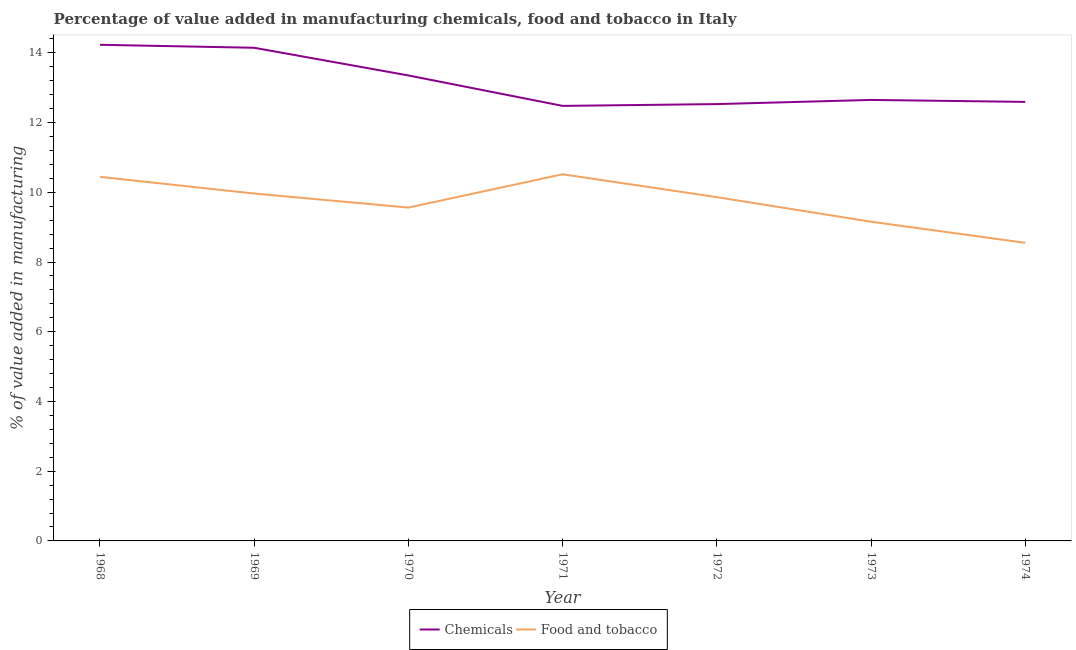How many different coloured lines are there?
Offer a terse response. 2. Does the line corresponding to value added by manufacturing food and tobacco intersect with the line corresponding to value added by  manufacturing chemicals?
Make the answer very short. No. What is the value added by  manufacturing chemicals in 1972?
Your answer should be compact. 12.53. Across all years, what is the maximum value added by  manufacturing chemicals?
Offer a very short reply. 14.23. Across all years, what is the minimum value added by  manufacturing chemicals?
Keep it short and to the point. 12.48. In which year was the value added by  manufacturing chemicals maximum?
Offer a terse response. 1968. In which year was the value added by  manufacturing chemicals minimum?
Your response must be concise. 1971. What is the total value added by manufacturing food and tobacco in the graph?
Your answer should be very brief. 68.05. What is the difference between the value added by  manufacturing chemicals in 1972 and that in 1974?
Your answer should be compact. -0.06. What is the difference between the value added by manufacturing food and tobacco in 1968 and the value added by  manufacturing chemicals in 1973?
Your answer should be compact. -2.21. What is the average value added by manufacturing food and tobacco per year?
Provide a succinct answer. 9.72. In the year 1969, what is the difference between the value added by  manufacturing chemicals and value added by manufacturing food and tobacco?
Offer a terse response. 4.18. In how many years, is the value added by  manufacturing chemicals greater than 14 %?
Give a very brief answer. 2. What is the ratio of the value added by manufacturing food and tobacco in 1971 to that in 1974?
Make the answer very short. 1.23. What is the difference between the highest and the second highest value added by  manufacturing chemicals?
Your answer should be very brief. 0.09. What is the difference between the highest and the lowest value added by  manufacturing chemicals?
Offer a very short reply. 1.75. Is the value added by  manufacturing chemicals strictly less than the value added by manufacturing food and tobacco over the years?
Make the answer very short. No. How many lines are there?
Your answer should be compact. 2. How many years are there in the graph?
Provide a succinct answer. 7. What is the difference between two consecutive major ticks on the Y-axis?
Your answer should be very brief. 2. Are the values on the major ticks of Y-axis written in scientific E-notation?
Offer a very short reply. No. Does the graph contain grids?
Provide a short and direct response. No. How many legend labels are there?
Your answer should be compact. 2. What is the title of the graph?
Ensure brevity in your answer.  Percentage of value added in manufacturing chemicals, food and tobacco in Italy. What is the label or title of the Y-axis?
Your response must be concise. % of value added in manufacturing. What is the % of value added in manufacturing in Chemicals in 1968?
Keep it short and to the point. 14.23. What is the % of value added in manufacturing of Food and tobacco in 1968?
Your answer should be very brief. 10.44. What is the % of value added in manufacturing of Chemicals in 1969?
Your response must be concise. 14.14. What is the % of value added in manufacturing in Food and tobacco in 1969?
Provide a short and direct response. 9.96. What is the % of value added in manufacturing of Chemicals in 1970?
Your answer should be compact. 13.35. What is the % of value added in manufacturing in Food and tobacco in 1970?
Offer a terse response. 9.56. What is the % of value added in manufacturing in Chemicals in 1971?
Your answer should be compact. 12.48. What is the % of value added in manufacturing in Food and tobacco in 1971?
Offer a terse response. 10.52. What is the % of value added in manufacturing in Chemicals in 1972?
Offer a terse response. 12.53. What is the % of value added in manufacturing in Food and tobacco in 1972?
Offer a very short reply. 9.86. What is the % of value added in manufacturing in Chemicals in 1973?
Keep it short and to the point. 12.65. What is the % of value added in manufacturing of Food and tobacco in 1973?
Give a very brief answer. 9.16. What is the % of value added in manufacturing in Chemicals in 1974?
Offer a terse response. 12.59. What is the % of value added in manufacturing in Food and tobacco in 1974?
Offer a terse response. 8.55. Across all years, what is the maximum % of value added in manufacturing in Chemicals?
Your answer should be compact. 14.23. Across all years, what is the maximum % of value added in manufacturing in Food and tobacco?
Ensure brevity in your answer.  10.52. Across all years, what is the minimum % of value added in manufacturing of Chemicals?
Your answer should be compact. 12.48. Across all years, what is the minimum % of value added in manufacturing in Food and tobacco?
Keep it short and to the point. 8.55. What is the total % of value added in manufacturing in Chemicals in the graph?
Make the answer very short. 91.98. What is the total % of value added in manufacturing in Food and tobacco in the graph?
Offer a very short reply. 68.05. What is the difference between the % of value added in manufacturing in Chemicals in 1968 and that in 1969?
Offer a very short reply. 0.09. What is the difference between the % of value added in manufacturing of Food and tobacco in 1968 and that in 1969?
Ensure brevity in your answer.  0.48. What is the difference between the % of value added in manufacturing of Chemicals in 1968 and that in 1970?
Give a very brief answer. 0.88. What is the difference between the % of value added in manufacturing in Food and tobacco in 1968 and that in 1970?
Provide a succinct answer. 0.88. What is the difference between the % of value added in manufacturing of Chemicals in 1968 and that in 1971?
Keep it short and to the point. 1.75. What is the difference between the % of value added in manufacturing of Food and tobacco in 1968 and that in 1971?
Offer a very short reply. -0.07. What is the difference between the % of value added in manufacturing in Chemicals in 1968 and that in 1972?
Offer a terse response. 1.7. What is the difference between the % of value added in manufacturing of Food and tobacco in 1968 and that in 1972?
Keep it short and to the point. 0.58. What is the difference between the % of value added in manufacturing of Chemicals in 1968 and that in 1973?
Ensure brevity in your answer.  1.58. What is the difference between the % of value added in manufacturing of Food and tobacco in 1968 and that in 1973?
Your answer should be very brief. 1.29. What is the difference between the % of value added in manufacturing in Chemicals in 1968 and that in 1974?
Make the answer very short. 1.64. What is the difference between the % of value added in manufacturing of Food and tobacco in 1968 and that in 1974?
Keep it short and to the point. 1.89. What is the difference between the % of value added in manufacturing in Chemicals in 1969 and that in 1970?
Your answer should be very brief. 0.79. What is the difference between the % of value added in manufacturing of Food and tobacco in 1969 and that in 1970?
Give a very brief answer. 0.4. What is the difference between the % of value added in manufacturing in Chemicals in 1969 and that in 1971?
Offer a very short reply. 1.67. What is the difference between the % of value added in manufacturing of Food and tobacco in 1969 and that in 1971?
Your response must be concise. -0.55. What is the difference between the % of value added in manufacturing of Chemicals in 1969 and that in 1972?
Provide a succinct answer. 1.62. What is the difference between the % of value added in manufacturing in Food and tobacco in 1969 and that in 1972?
Your answer should be very brief. 0.1. What is the difference between the % of value added in manufacturing in Chemicals in 1969 and that in 1973?
Your answer should be compact. 1.5. What is the difference between the % of value added in manufacturing in Food and tobacco in 1969 and that in 1973?
Your response must be concise. 0.81. What is the difference between the % of value added in manufacturing in Chemicals in 1969 and that in 1974?
Ensure brevity in your answer.  1.55. What is the difference between the % of value added in manufacturing of Food and tobacco in 1969 and that in 1974?
Offer a terse response. 1.41. What is the difference between the % of value added in manufacturing in Chemicals in 1970 and that in 1971?
Your answer should be very brief. 0.87. What is the difference between the % of value added in manufacturing of Food and tobacco in 1970 and that in 1971?
Offer a terse response. -0.95. What is the difference between the % of value added in manufacturing in Chemicals in 1970 and that in 1972?
Your answer should be very brief. 0.82. What is the difference between the % of value added in manufacturing in Food and tobacco in 1970 and that in 1972?
Provide a succinct answer. -0.3. What is the difference between the % of value added in manufacturing of Chemicals in 1970 and that in 1973?
Offer a terse response. 0.7. What is the difference between the % of value added in manufacturing in Food and tobacco in 1970 and that in 1973?
Make the answer very short. 0.41. What is the difference between the % of value added in manufacturing in Chemicals in 1970 and that in 1974?
Offer a terse response. 0.76. What is the difference between the % of value added in manufacturing of Food and tobacco in 1970 and that in 1974?
Offer a terse response. 1.01. What is the difference between the % of value added in manufacturing in Chemicals in 1971 and that in 1972?
Your response must be concise. -0.05. What is the difference between the % of value added in manufacturing of Food and tobacco in 1971 and that in 1972?
Give a very brief answer. 0.66. What is the difference between the % of value added in manufacturing of Chemicals in 1971 and that in 1973?
Your answer should be very brief. -0.17. What is the difference between the % of value added in manufacturing in Food and tobacco in 1971 and that in 1973?
Your response must be concise. 1.36. What is the difference between the % of value added in manufacturing in Chemicals in 1971 and that in 1974?
Provide a short and direct response. -0.11. What is the difference between the % of value added in manufacturing of Food and tobacco in 1971 and that in 1974?
Offer a terse response. 1.97. What is the difference between the % of value added in manufacturing of Chemicals in 1972 and that in 1973?
Ensure brevity in your answer.  -0.12. What is the difference between the % of value added in manufacturing in Food and tobacco in 1972 and that in 1973?
Your answer should be compact. 0.7. What is the difference between the % of value added in manufacturing in Chemicals in 1972 and that in 1974?
Ensure brevity in your answer.  -0.06. What is the difference between the % of value added in manufacturing in Food and tobacco in 1972 and that in 1974?
Your answer should be very brief. 1.31. What is the difference between the % of value added in manufacturing in Chemicals in 1973 and that in 1974?
Your answer should be compact. 0.06. What is the difference between the % of value added in manufacturing in Food and tobacco in 1973 and that in 1974?
Your answer should be compact. 0.61. What is the difference between the % of value added in manufacturing in Chemicals in 1968 and the % of value added in manufacturing in Food and tobacco in 1969?
Offer a terse response. 4.27. What is the difference between the % of value added in manufacturing of Chemicals in 1968 and the % of value added in manufacturing of Food and tobacco in 1970?
Offer a terse response. 4.67. What is the difference between the % of value added in manufacturing of Chemicals in 1968 and the % of value added in manufacturing of Food and tobacco in 1971?
Ensure brevity in your answer.  3.71. What is the difference between the % of value added in manufacturing of Chemicals in 1968 and the % of value added in manufacturing of Food and tobacco in 1972?
Your response must be concise. 4.37. What is the difference between the % of value added in manufacturing in Chemicals in 1968 and the % of value added in manufacturing in Food and tobacco in 1973?
Give a very brief answer. 5.08. What is the difference between the % of value added in manufacturing of Chemicals in 1968 and the % of value added in manufacturing of Food and tobacco in 1974?
Ensure brevity in your answer.  5.68. What is the difference between the % of value added in manufacturing in Chemicals in 1969 and the % of value added in manufacturing in Food and tobacco in 1970?
Provide a succinct answer. 4.58. What is the difference between the % of value added in manufacturing in Chemicals in 1969 and the % of value added in manufacturing in Food and tobacco in 1971?
Give a very brief answer. 3.63. What is the difference between the % of value added in manufacturing of Chemicals in 1969 and the % of value added in manufacturing of Food and tobacco in 1972?
Ensure brevity in your answer.  4.28. What is the difference between the % of value added in manufacturing in Chemicals in 1969 and the % of value added in manufacturing in Food and tobacco in 1973?
Your answer should be very brief. 4.99. What is the difference between the % of value added in manufacturing in Chemicals in 1969 and the % of value added in manufacturing in Food and tobacco in 1974?
Ensure brevity in your answer.  5.59. What is the difference between the % of value added in manufacturing in Chemicals in 1970 and the % of value added in manufacturing in Food and tobacco in 1971?
Your answer should be very brief. 2.83. What is the difference between the % of value added in manufacturing in Chemicals in 1970 and the % of value added in manufacturing in Food and tobacco in 1972?
Keep it short and to the point. 3.49. What is the difference between the % of value added in manufacturing of Chemicals in 1970 and the % of value added in manufacturing of Food and tobacco in 1973?
Give a very brief answer. 4.2. What is the difference between the % of value added in manufacturing of Chemicals in 1970 and the % of value added in manufacturing of Food and tobacco in 1974?
Provide a short and direct response. 4.8. What is the difference between the % of value added in manufacturing of Chemicals in 1971 and the % of value added in manufacturing of Food and tobacco in 1972?
Make the answer very short. 2.62. What is the difference between the % of value added in manufacturing in Chemicals in 1971 and the % of value added in manufacturing in Food and tobacco in 1973?
Provide a succinct answer. 3.32. What is the difference between the % of value added in manufacturing of Chemicals in 1971 and the % of value added in manufacturing of Food and tobacco in 1974?
Provide a succinct answer. 3.93. What is the difference between the % of value added in manufacturing of Chemicals in 1972 and the % of value added in manufacturing of Food and tobacco in 1973?
Offer a terse response. 3.37. What is the difference between the % of value added in manufacturing of Chemicals in 1972 and the % of value added in manufacturing of Food and tobacco in 1974?
Offer a terse response. 3.98. What is the difference between the % of value added in manufacturing of Chemicals in 1973 and the % of value added in manufacturing of Food and tobacco in 1974?
Ensure brevity in your answer.  4.1. What is the average % of value added in manufacturing in Chemicals per year?
Ensure brevity in your answer.  13.14. What is the average % of value added in manufacturing in Food and tobacco per year?
Give a very brief answer. 9.72. In the year 1968, what is the difference between the % of value added in manufacturing of Chemicals and % of value added in manufacturing of Food and tobacco?
Offer a very short reply. 3.79. In the year 1969, what is the difference between the % of value added in manufacturing in Chemicals and % of value added in manufacturing in Food and tobacco?
Offer a very short reply. 4.18. In the year 1970, what is the difference between the % of value added in manufacturing of Chemicals and % of value added in manufacturing of Food and tobacco?
Ensure brevity in your answer.  3.79. In the year 1971, what is the difference between the % of value added in manufacturing of Chemicals and % of value added in manufacturing of Food and tobacco?
Your answer should be very brief. 1.96. In the year 1972, what is the difference between the % of value added in manufacturing of Chemicals and % of value added in manufacturing of Food and tobacco?
Provide a succinct answer. 2.67. In the year 1973, what is the difference between the % of value added in manufacturing of Chemicals and % of value added in manufacturing of Food and tobacco?
Offer a very short reply. 3.49. In the year 1974, what is the difference between the % of value added in manufacturing in Chemicals and % of value added in manufacturing in Food and tobacco?
Your response must be concise. 4.04. What is the ratio of the % of value added in manufacturing in Chemicals in 1968 to that in 1969?
Offer a terse response. 1.01. What is the ratio of the % of value added in manufacturing in Food and tobacco in 1968 to that in 1969?
Offer a very short reply. 1.05. What is the ratio of the % of value added in manufacturing in Chemicals in 1968 to that in 1970?
Your answer should be very brief. 1.07. What is the ratio of the % of value added in manufacturing of Food and tobacco in 1968 to that in 1970?
Provide a succinct answer. 1.09. What is the ratio of the % of value added in manufacturing in Chemicals in 1968 to that in 1971?
Keep it short and to the point. 1.14. What is the ratio of the % of value added in manufacturing of Food and tobacco in 1968 to that in 1971?
Offer a terse response. 0.99. What is the ratio of the % of value added in manufacturing in Chemicals in 1968 to that in 1972?
Your response must be concise. 1.14. What is the ratio of the % of value added in manufacturing in Food and tobacco in 1968 to that in 1972?
Offer a very short reply. 1.06. What is the ratio of the % of value added in manufacturing in Chemicals in 1968 to that in 1973?
Your response must be concise. 1.13. What is the ratio of the % of value added in manufacturing in Food and tobacco in 1968 to that in 1973?
Make the answer very short. 1.14. What is the ratio of the % of value added in manufacturing of Chemicals in 1968 to that in 1974?
Your answer should be very brief. 1.13. What is the ratio of the % of value added in manufacturing in Food and tobacco in 1968 to that in 1974?
Give a very brief answer. 1.22. What is the ratio of the % of value added in manufacturing in Chemicals in 1969 to that in 1970?
Give a very brief answer. 1.06. What is the ratio of the % of value added in manufacturing of Food and tobacco in 1969 to that in 1970?
Provide a short and direct response. 1.04. What is the ratio of the % of value added in manufacturing of Chemicals in 1969 to that in 1971?
Make the answer very short. 1.13. What is the ratio of the % of value added in manufacturing of Food and tobacco in 1969 to that in 1971?
Your answer should be very brief. 0.95. What is the ratio of the % of value added in manufacturing of Chemicals in 1969 to that in 1972?
Your answer should be compact. 1.13. What is the ratio of the % of value added in manufacturing of Food and tobacco in 1969 to that in 1972?
Ensure brevity in your answer.  1.01. What is the ratio of the % of value added in manufacturing in Chemicals in 1969 to that in 1973?
Make the answer very short. 1.12. What is the ratio of the % of value added in manufacturing of Food and tobacco in 1969 to that in 1973?
Give a very brief answer. 1.09. What is the ratio of the % of value added in manufacturing in Chemicals in 1969 to that in 1974?
Your answer should be very brief. 1.12. What is the ratio of the % of value added in manufacturing in Food and tobacco in 1969 to that in 1974?
Give a very brief answer. 1.17. What is the ratio of the % of value added in manufacturing of Chemicals in 1970 to that in 1971?
Your answer should be very brief. 1.07. What is the ratio of the % of value added in manufacturing in Food and tobacco in 1970 to that in 1971?
Your response must be concise. 0.91. What is the ratio of the % of value added in manufacturing of Chemicals in 1970 to that in 1972?
Provide a short and direct response. 1.07. What is the ratio of the % of value added in manufacturing of Food and tobacco in 1970 to that in 1972?
Make the answer very short. 0.97. What is the ratio of the % of value added in manufacturing in Chemicals in 1970 to that in 1973?
Provide a succinct answer. 1.06. What is the ratio of the % of value added in manufacturing of Food and tobacco in 1970 to that in 1973?
Make the answer very short. 1.04. What is the ratio of the % of value added in manufacturing of Chemicals in 1970 to that in 1974?
Your response must be concise. 1.06. What is the ratio of the % of value added in manufacturing of Food and tobacco in 1970 to that in 1974?
Give a very brief answer. 1.12. What is the ratio of the % of value added in manufacturing in Food and tobacco in 1971 to that in 1972?
Keep it short and to the point. 1.07. What is the ratio of the % of value added in manufacturing of Chemicals in 1971 to that in 1973?
Offer a very short reply. 0.99. What is the ratio of the % of value added in manufacturing in Food and tobacco in 1971 to that in 1973?
Offer a very short reply. 1.15. What is the ratio of the % of value added in manufacturing in Chemicals in 1971 to that in 1974?
Provide a succinct answer. 0.99. What is the ratio of the % of value added in manufacturing of Food and tobacco in 1971 to that in 1974?
Ensure brevity in your answer.  1.23. What is the ratio of the % of value added in manufacturing in Chemicals in 1972 to that in 1973?
Give a very brief answer. 0.99. What is the ratio of the % of value added in manufacturing of Food and tobacco in 1972 to that in 1973?
Your answer should be compact. 1.08. What is the ratio of the % of value added in manufacturing of Food and tobacco in 1972 to that in 1974?
Give a very brief answer. 1.15. What is the ratio of the % of value added in manufacturing in Food and tobacco in 1973 to that in 1974?
Your answer should be compact. 1.07. What is the difference between the highest and the second highest % of value added in manufacturing in Chemicals?
Provide a short and direct response. 0.09. What is the difference between the highest and the second highest % of value added in manufacturing in Food and tobacco?
Your answer should be compact. 0.07. What is the difference between the highest and the lowest % of value added in manufacturing of Chemicals?
Provide a short and direct response. 1.75. What is the difference between the highest and the lowest % of value added in manufacturing in Food and tobacco?
Ensure brevity in your answer.  1.97. 